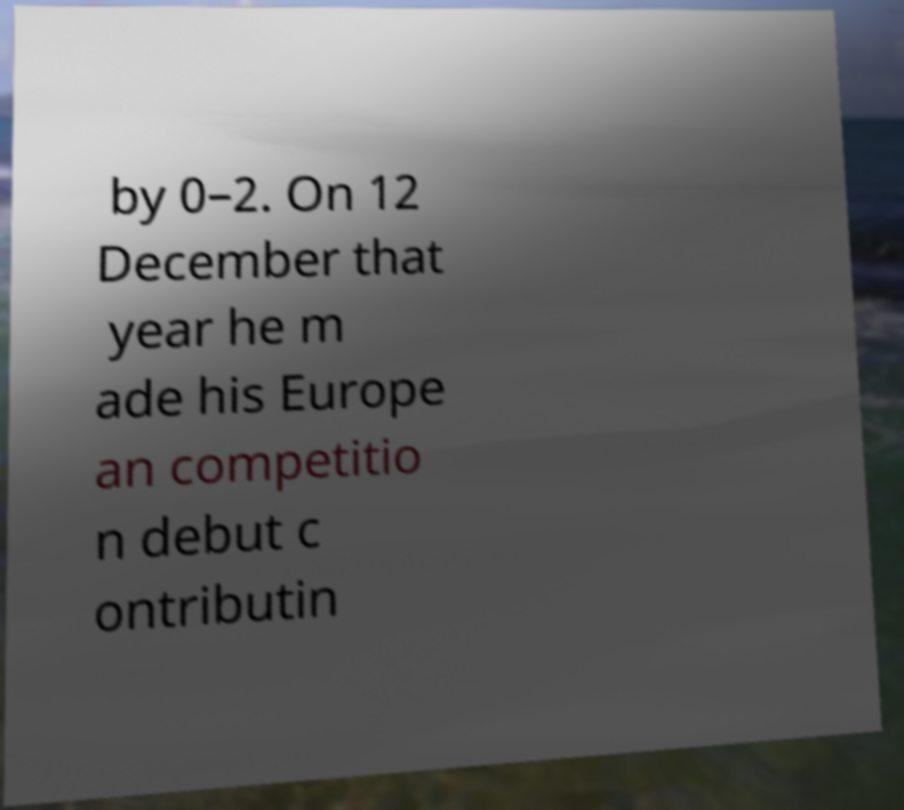Please read and relay the text visible in this image. What does it say? by 0–2. On 12 December that year he m ade his Europe an competitio n debut c ontributin 